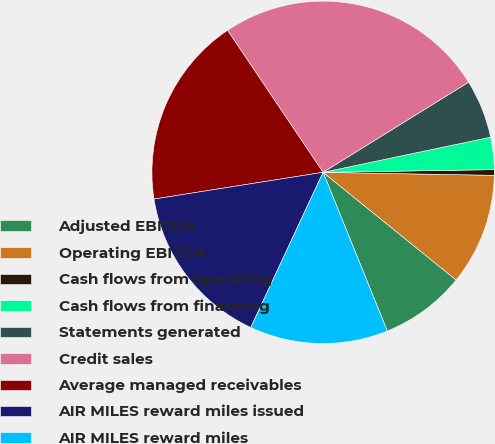Convert chart to OTSL. <chart><loc_0><loc_0><loc_500><loc_500><pie_chart><fcel>Adjusted EBITDA<fcel>Operating EBITDA<fcel>Cash flows from operating<fcel>Cash flows from financing<fcel>Statements generated<fcel>Credit sales<fcel>Average managed receivables<fcel>AIR MILES reward miles issued<fcel>AIR MILES reward miles<nl><fcel>8.05%<fcel>10.55%<fcel>0.53%<fcel>3.04%<fcel>5.54%<fcel>25.59%<fcel>18.07%<fcel>15.56%<fcel>13.06%<nl></chart> 